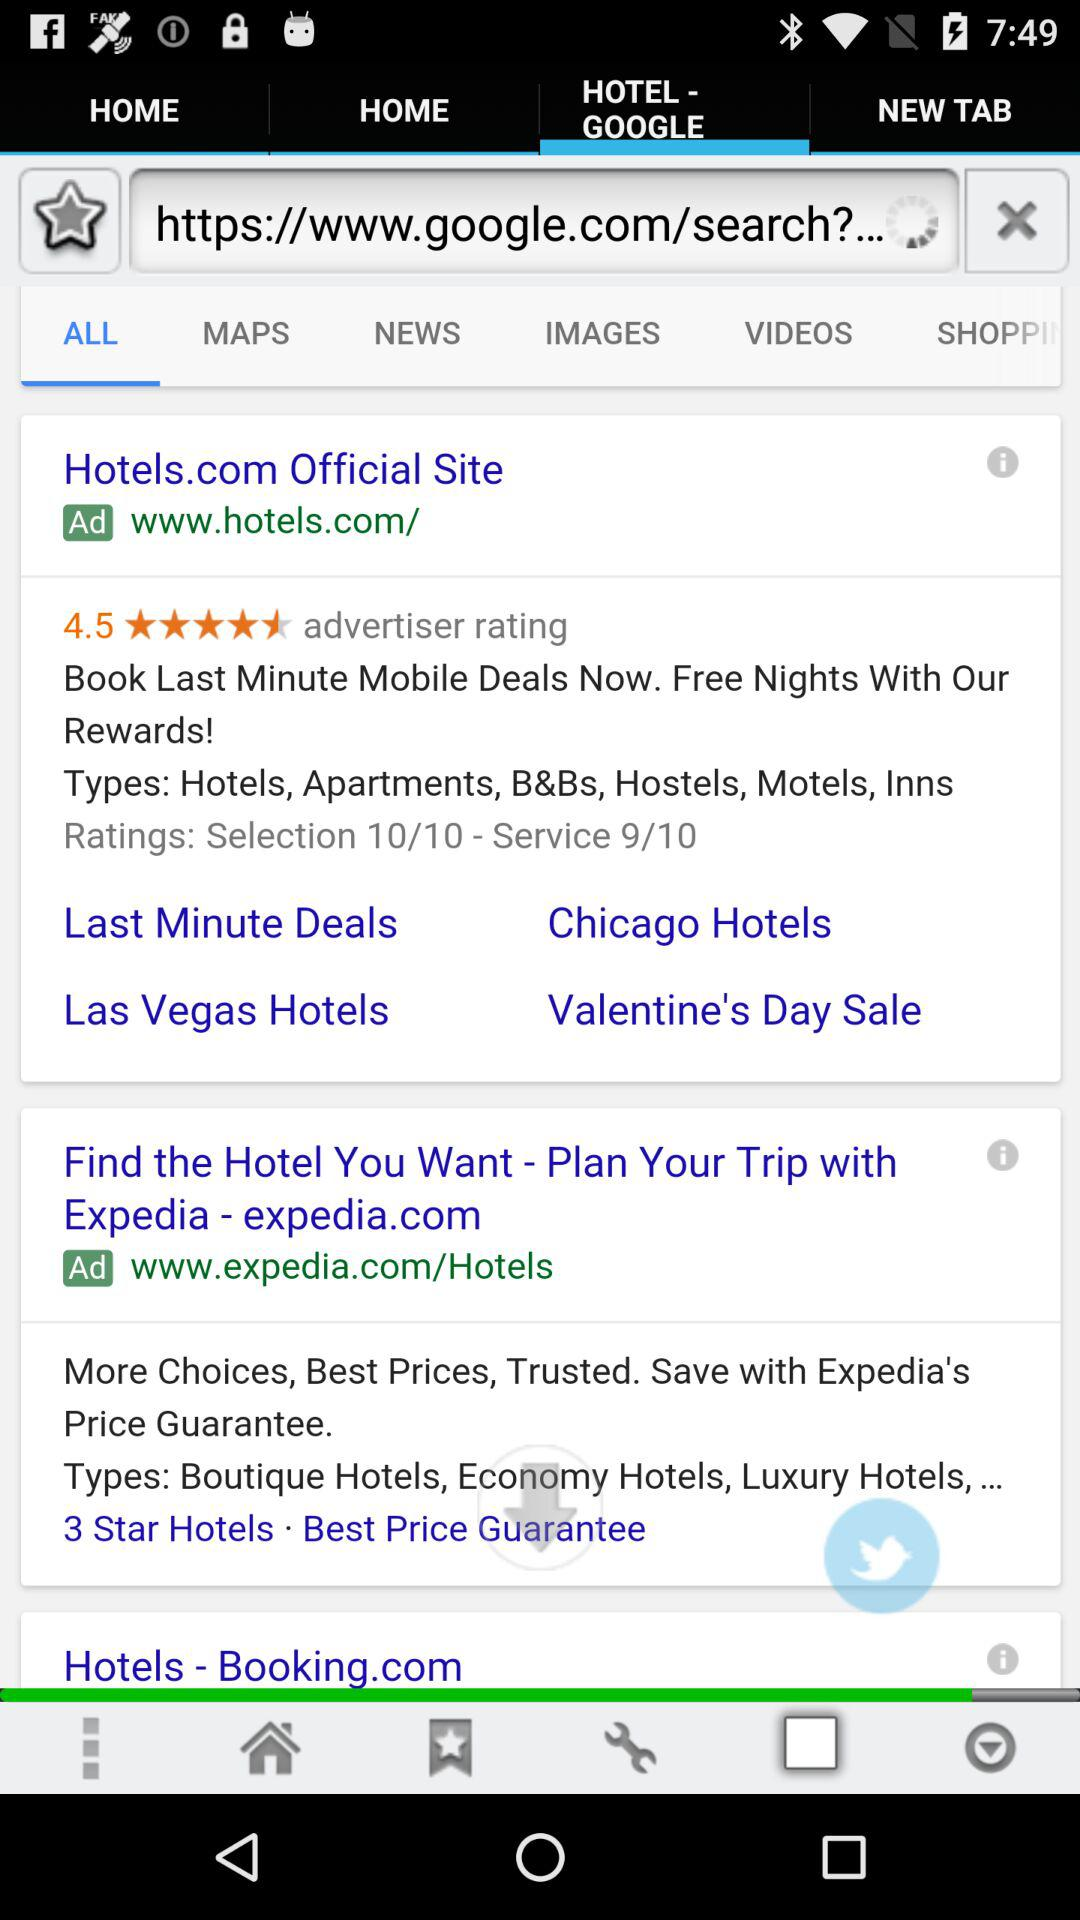What is the rating for service out of 10? The rating for service is 9 out of 10. 